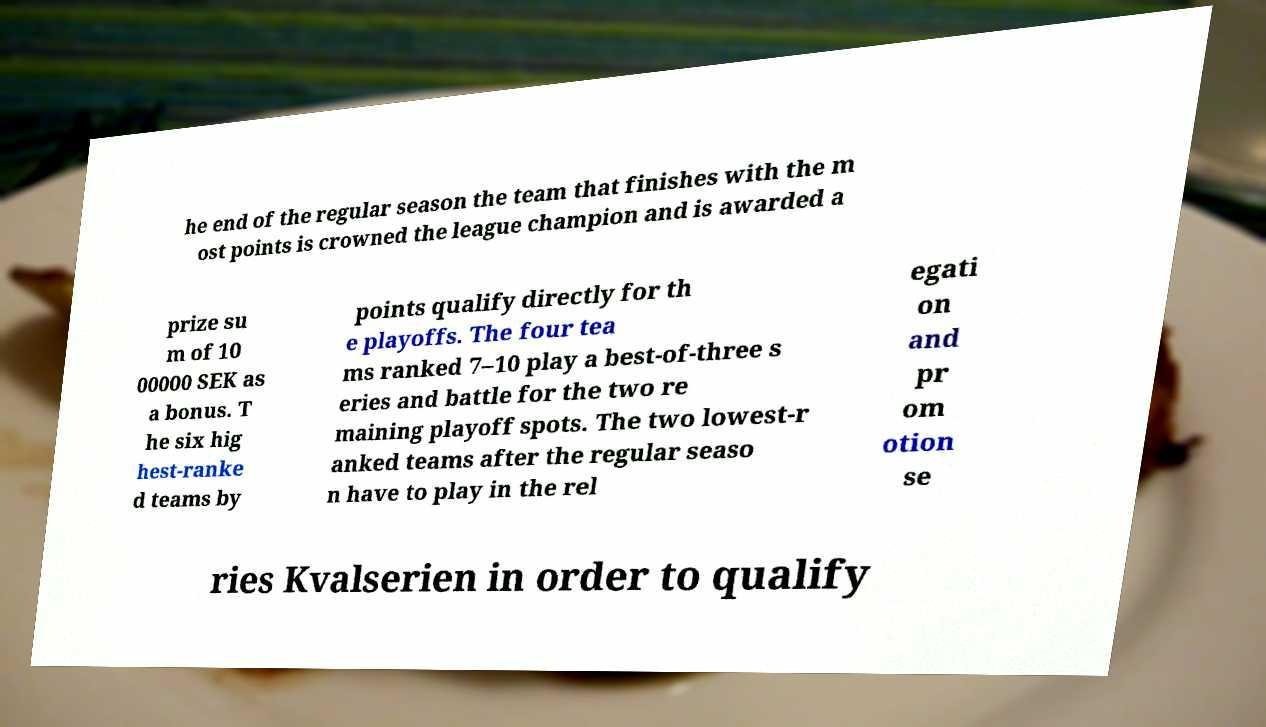What messages or text are displayed in this image? I need them in a readable, typed format. he end of the regular season the team that finishes with the m ost points is crowned the league champion and is awarded a prize su m of 10 00000 SEK as a bonus. T he six hig hest-ranke d teams by points qualify directly for th e playoffs. The four tea ms ranked 7–10 play a best-of-three s eries and battle for the two re maining playoff spots. The two lowest-r anked teams after the regular seaso n have to play in the rel egati on and pr om otion se ries Kvalserien in order to qualify 